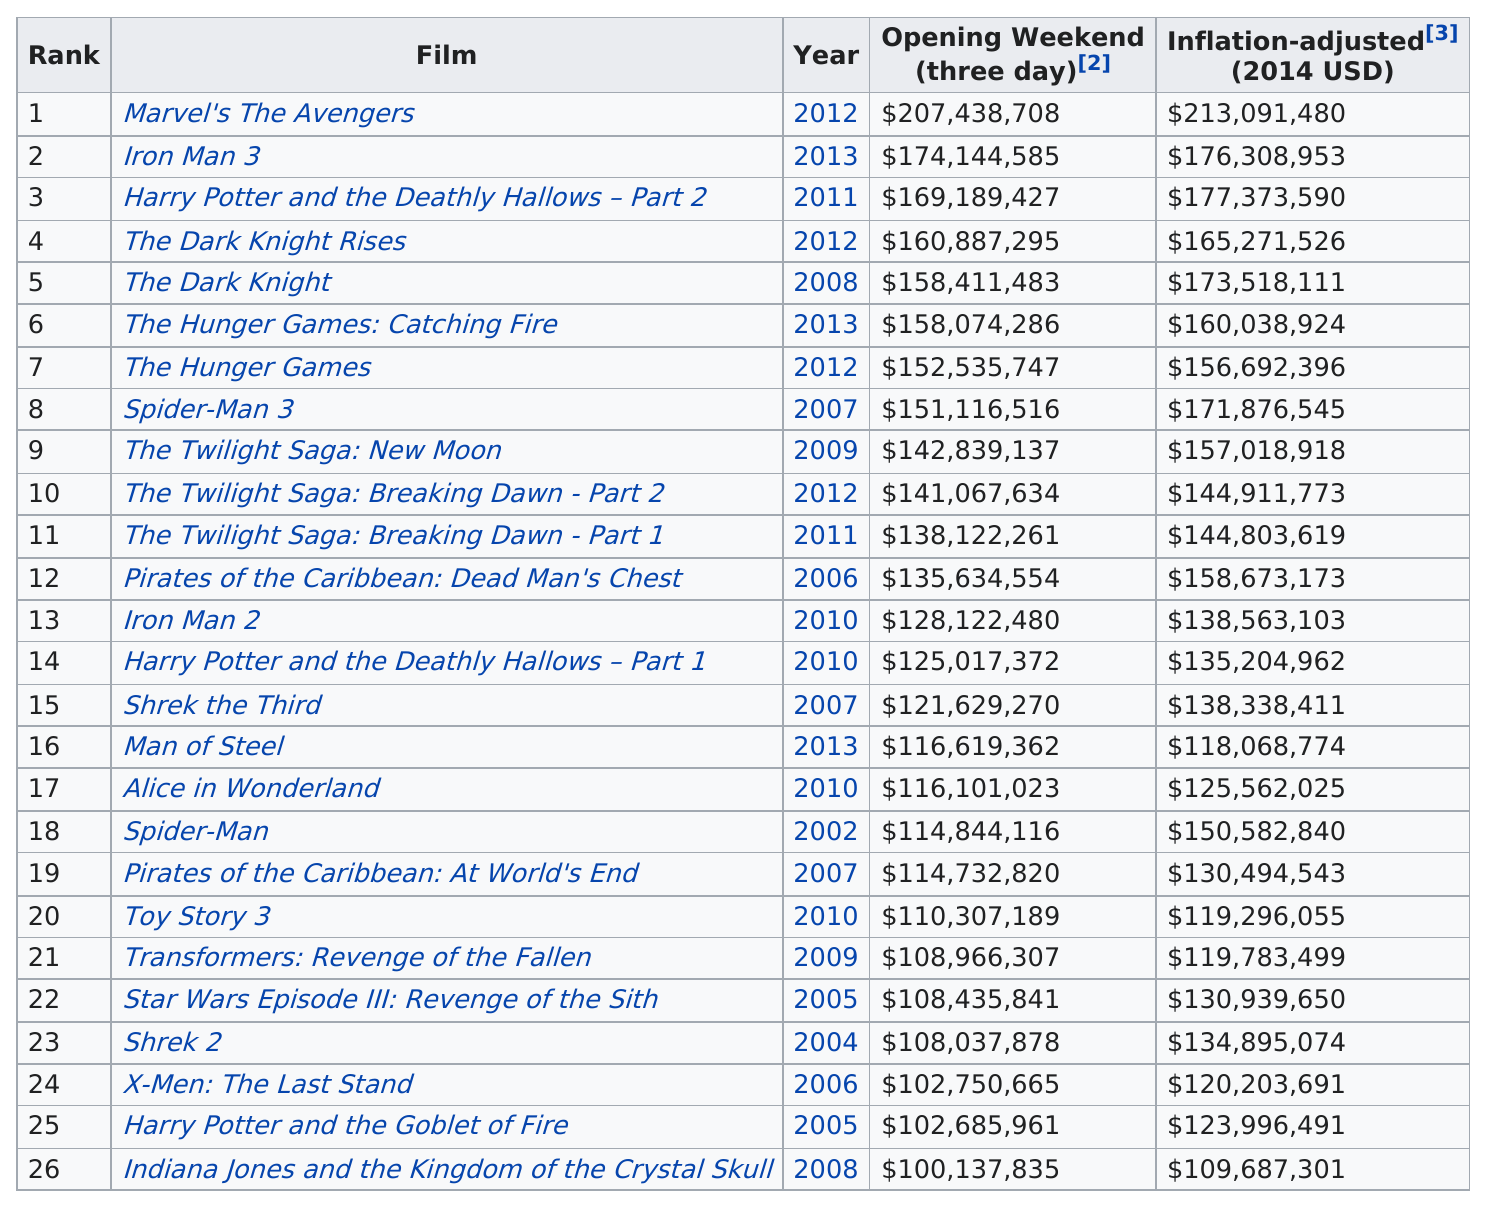Mention a couple of crucial points in this snapshot. Marvel's The Avengers, a movie that grossed at least $150,000,000, is a well-known and highly successful film. Three Twilight movies ranked in the top 26 for biggest opening weekends in the United States and Canada. Alice in Wonderland ranked after Man of Steel. Only Marvel's The Avengers released in 2012, with a worldwide opening of more than $390 million, is worthy of comparison to Avatar. The top three opening weekend films are Marvel's The Avengers, Iron Man 3, and Harry Potter and the Deathly Hallows - Part 2. 